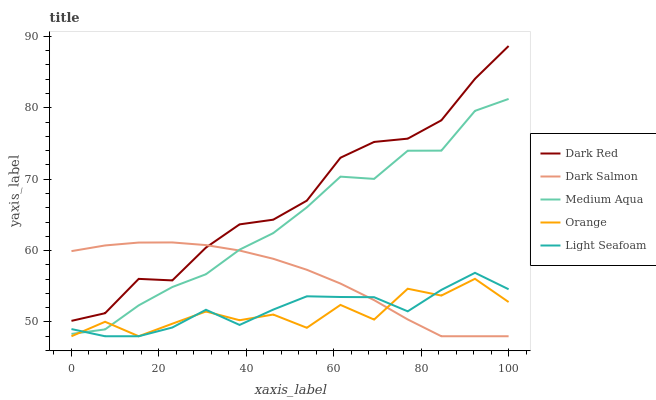Does Light Seafoam have the minimum area under the curve?
Answer yes or no. No. Does Light Seafoam have the maximum area under the curve?
Answer yes or no. No. Is Dark Red the smoothest?
Answer yes or no. No. Is Dark Red the roughest?
Answer yes or no. No. Does Dark Red have the lowest value?
Answer yes or no. No. Does Light Seafoam have the highest value?
Answer yes or no. No. Is Orange less than Dark Red?
Answer yes or no. Yes. Is Dark Red greater than Medium Aqua?
Answer yes or no. Yes. Does Orange intersect Dark Red?
Answer yes or no. No. 